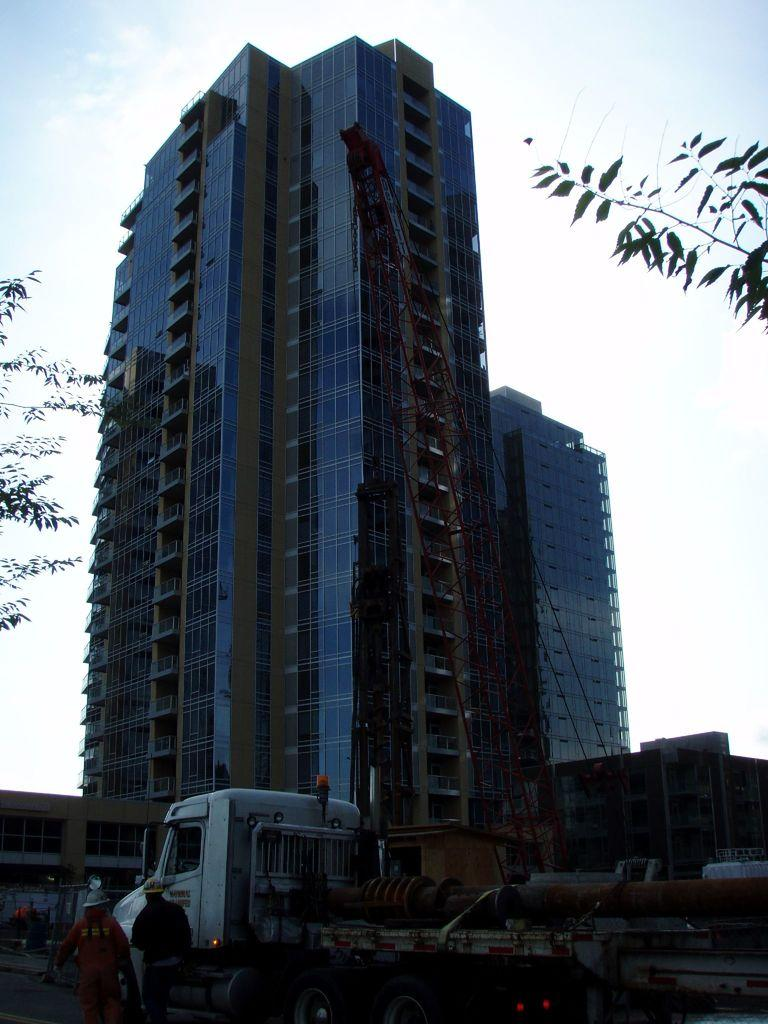What type of structure is visible in the image? There is a building in the image. What vehicle can be seen at the bottom of the image? There is a truck at the bottom of the image. How many people are visible to the left of the image? There are two persons to the left of the image. What is visible in the sky at the top of the image? There are clouds in the sky at the top of the image. What type of toys can be seen scattered around the truck in the image? There are no toys visible in the image; it only shows a truck and a building. Is there a bomb visible in the image? No, there is no bomb present in the image. 